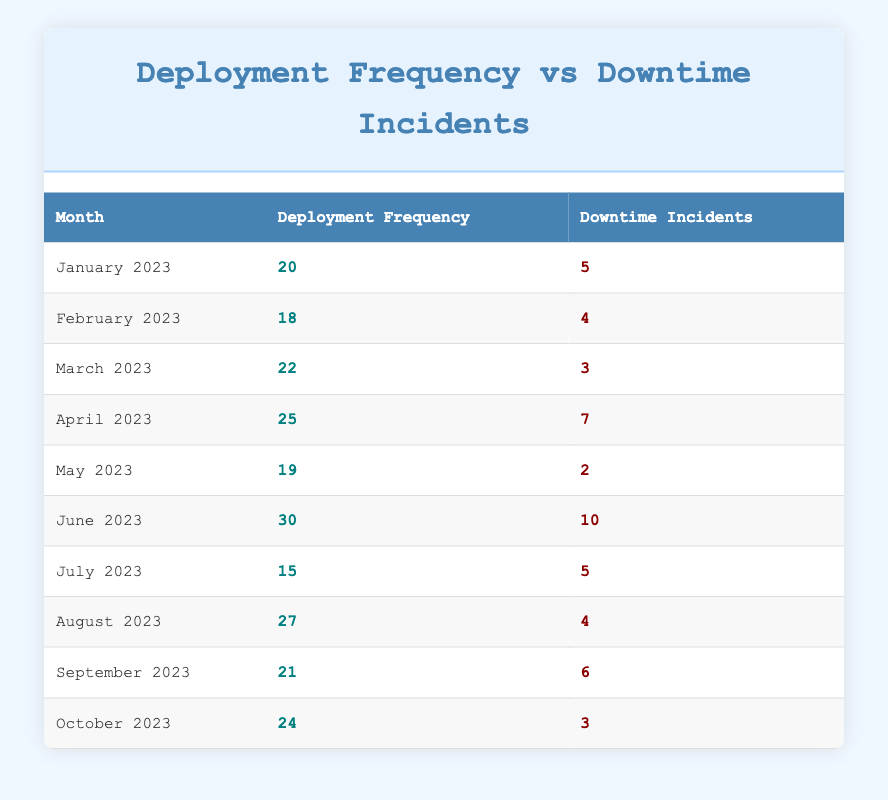What is the deployment frequency for March 2023? Referring to the table, the deployment frequency for March 2023 is found in the respective row under the "Deployment Frequency" column.
Answer: 22 How many downtime incidents were reported in June 2023? In the table, the number of downtime incidents for June 2023 is listed in the corresponding row under the "Downtime Incidents" column.
Answer: 10 What is the average deployment frequency from January to October 2023? To find the average deployment frequency, sum the deployment frequencies (20 + 18 + 22 + 25 + 19 + 30 + 15 + 27 + 21 + 24 =  211) and divide by the number of months (10). The average is 211/10 = 21.1.
Answer: 21.1 Did the deployment frequency in August 2023 exceed 25? By examining the table, the deployment frequency for August 2023 is 27, which is higher than 25.
Answer: Yes What is the total number of downtime incidents across all months from January to October 2023? We sum the downtime incidents for each month: (5 + 4 + 3 + 7 + 2 + 10 + 5 + 4 + 6 + 3 =  49). Therefore, the total number of incidents is 49.
Answer: 49 How many months had more than 5 downtime incidents? Looking at the table, the only months with more than 5 incidents are June 2023 (10) and April 2023 (7). Thus, there are 2 months in total.
Answer: 2 What is the difference between the highest deployment frequency and the lowest in the table? The highest deployment frequency is 30 in June 2023 and the lowest is 15 in July 2023. Calculating the difference: (30 - 15 = 15).
Answer: 15 Which month had the lowest downtime incidents? From the table, we check each month's downtime incidents; May 2023 has the lowest at 2 incidents.
Answer: May 2023 If deployment frequency increases, does downtime incidents tend to decrease based on the table data? By analyzing the table, it appears that lower frequencies do sometimes correlate with higher incidents (e.g., in June with 30 deployments and 10 incidents). However, there are exceptions (April 2023 with 25 deployments and 7 incidents). This suggests that the relationship is not consistently negative.
Answer: Not necessarily 